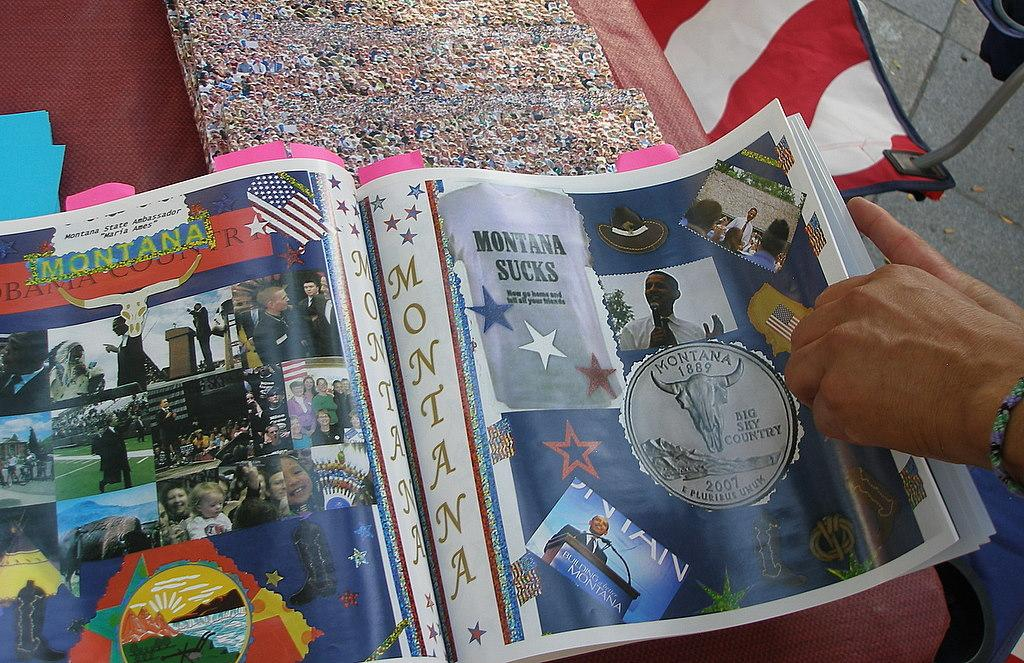<image>
Render a clear and concise summary of the photo. A magazine open to a page titled Montana Sucks. 